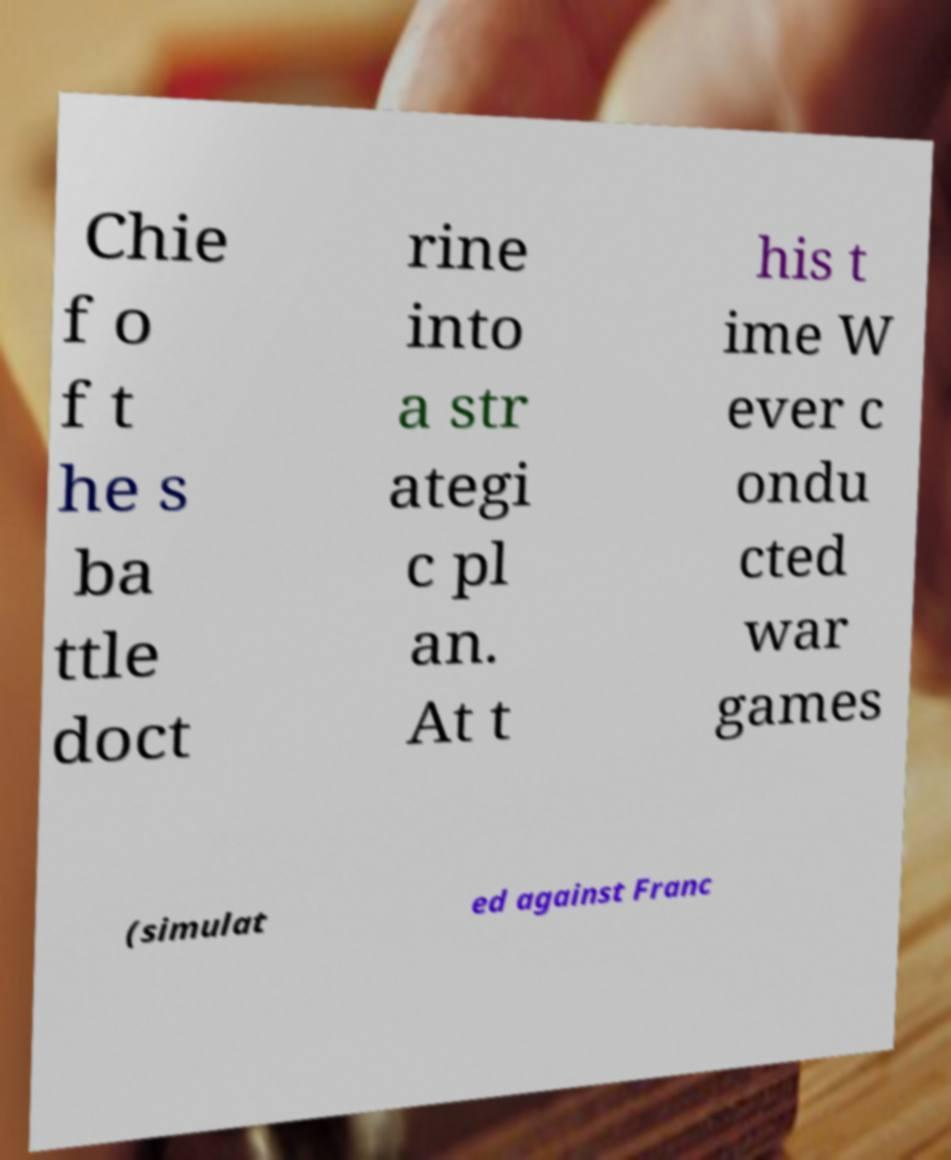Can you accurately transcribe the text from the provided image for me? Chie f o f t he s ba ttle doct rine into a str ategi c pl an. At t his t ime W ever c ondu cted war games (simulat ed against Franc 